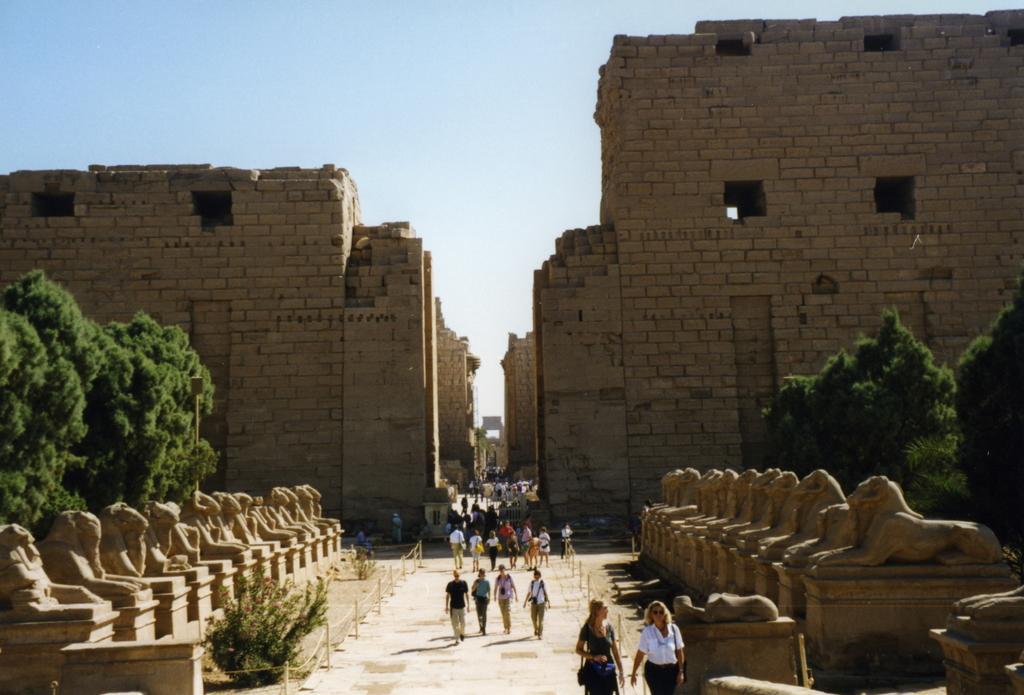Could you give a brief overview of what you see in this image? In this image there are so many people walking on the road which is in the middle of trees, sculptures and building. 